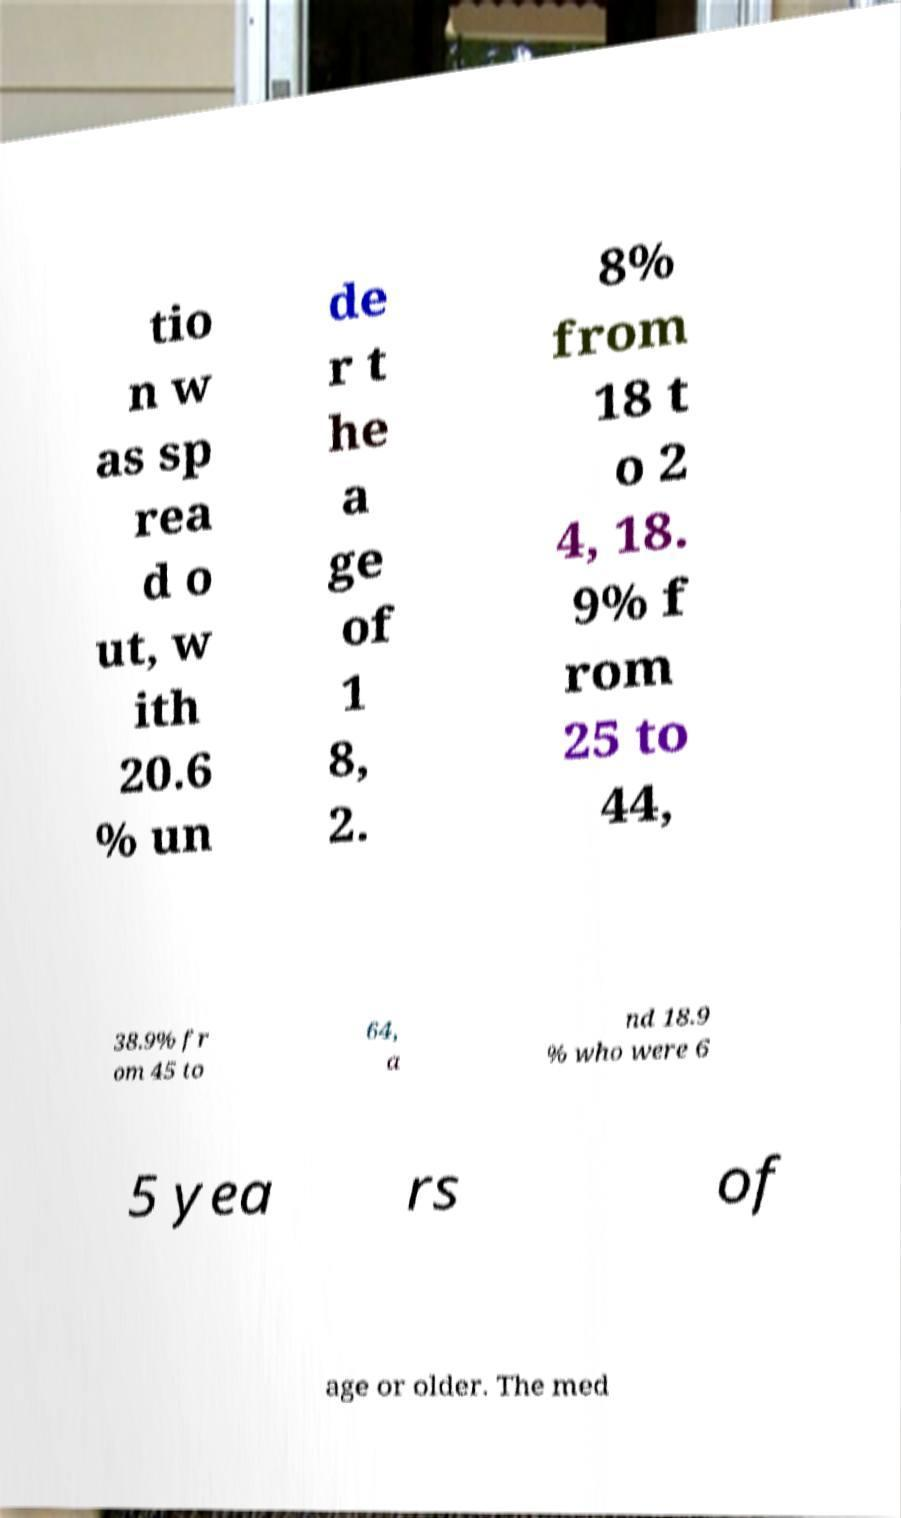What messages or text are displayed in this image? I need them in a readable, typed format. tio n w as sp rea d o ut, w ith 20.6 % un de r t he a ge of 1 8, 2. 8% from 18 t o 2 4, 18. 9% f rom 25 to 44, 38.9% fr om 45 to 64, a nd 18.9 % who were 6 5 yea rs of age or older. The med 